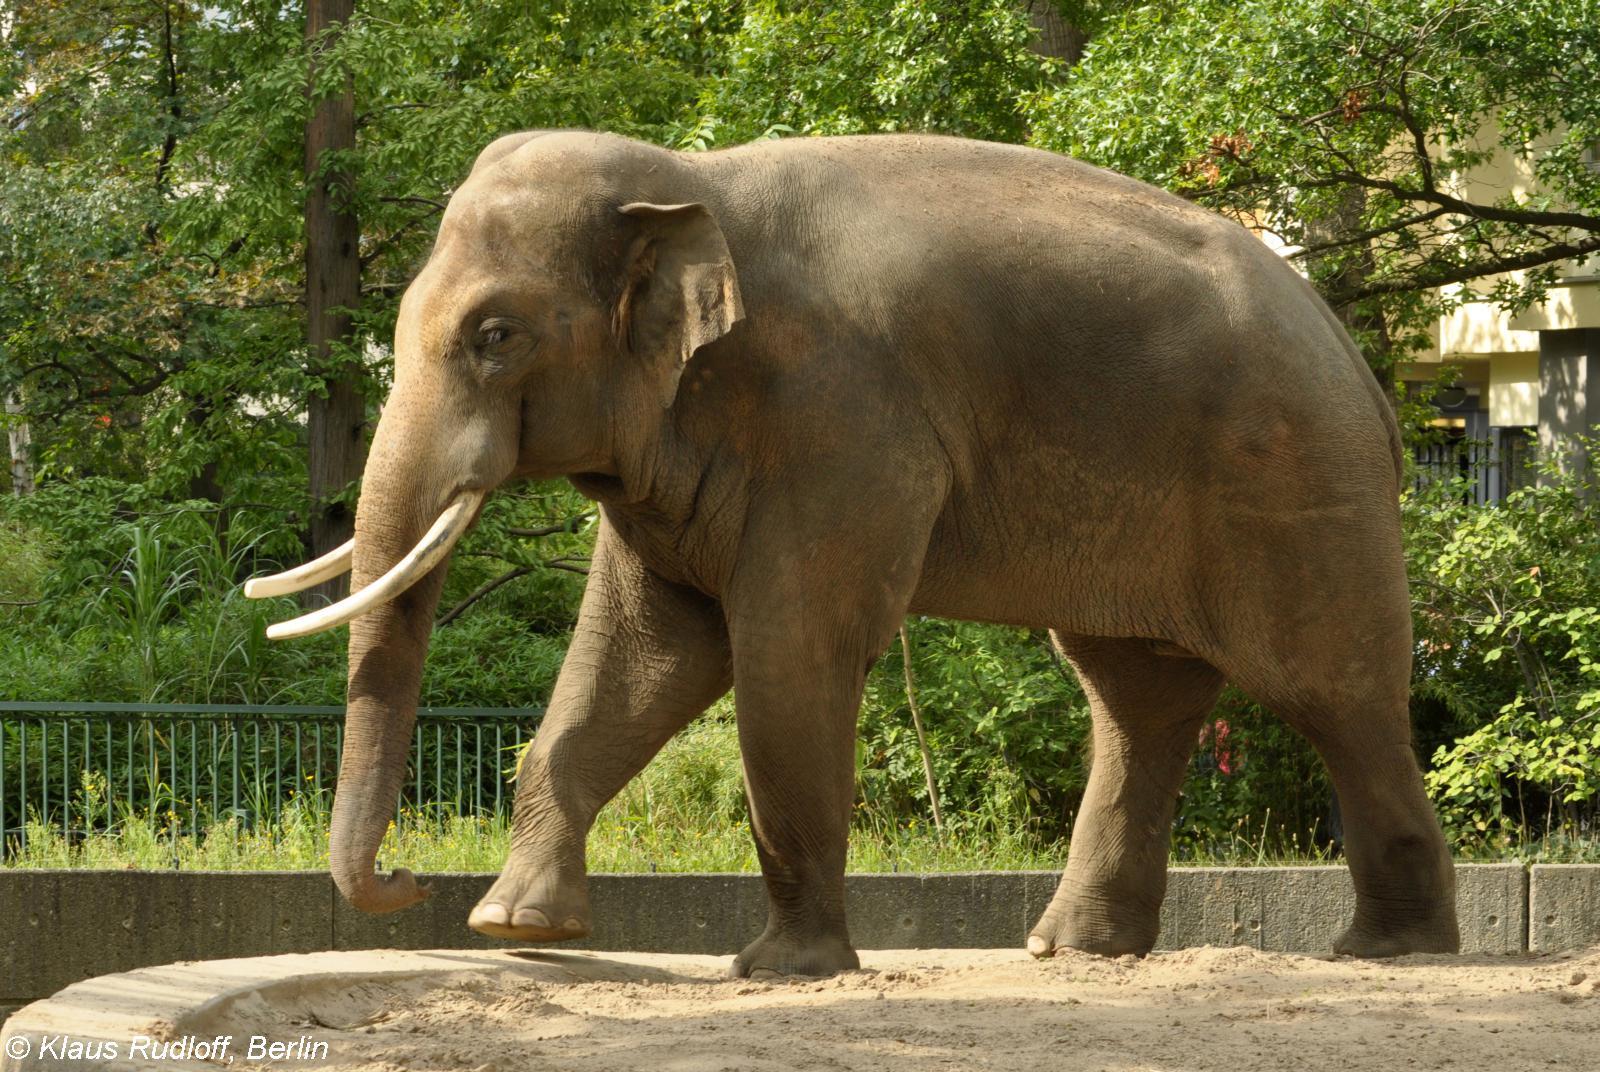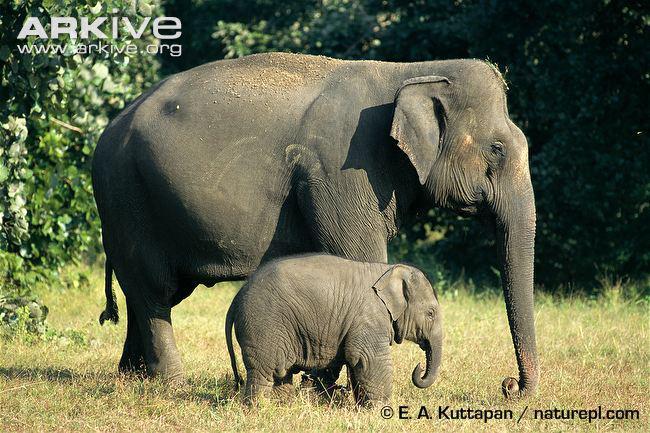The first image is the image on the left, the second image is the image on the right. Considering the images on both sides, is "there is one elephant on the left image" valid? Answer yes or no. Yes. 